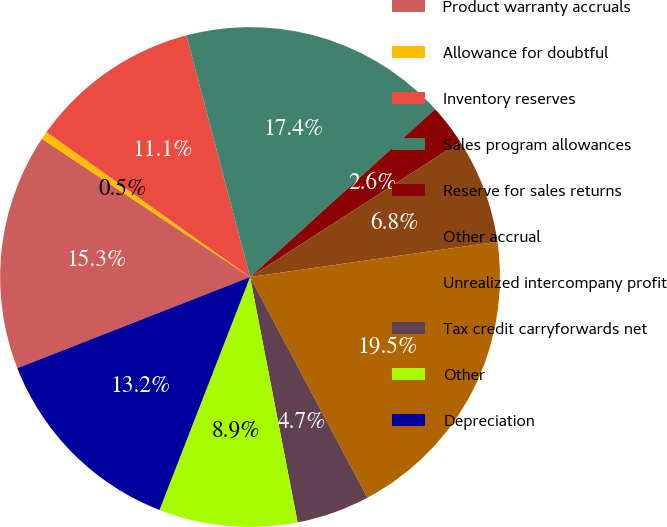<chart> <loc_0><loc_0><loc_500><loc_500><pie_chart><fcel>Product warranty accruals<fcel>Allowance for doubtful<fcel>Inventory reserves<fcel>Sales program allowances<fcel>Reserve for sales returns<fcel>Other accrual<fcel>Unrealized intercompany profit<fcel>Tax credit carryforwards net<fcel>Other<fcel>Depreciation<nl><fcel>15.27%<fcel>0.52%<fcel>11.05%<fcel>17.37%<fcel>2.63%<fcel>6.84%<fcel>19.48%<fcel>4.73%<fcel>8.95%<fcel>13.16%<nl></chart> 